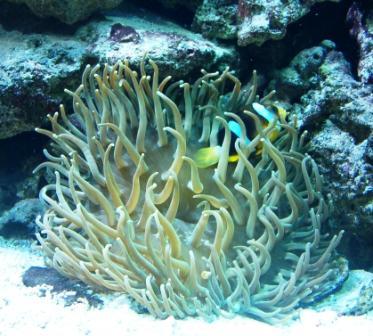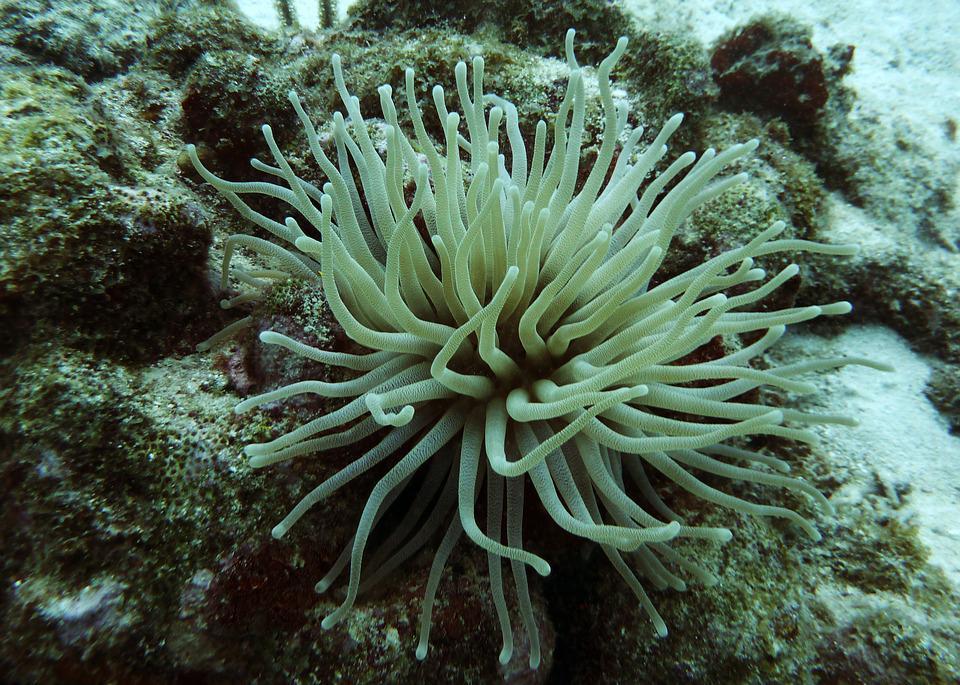The first image is the image on the left, the second image is the image on the right. Examine the images to the left and right. Is the description "Both images contain only sea anemones and rocks." accurate? Answer yes or no. Yes. The first image is the image on the left, the second image is the image on the right. Considering the images on both sides, is "The colors of the anemones are soft greens and blues." valid? Answer yes or no. Yes. 